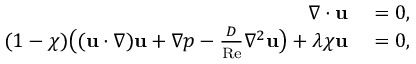Convert formula to latex. <formula><loc_0><loc_0><loc_500><loc_500>\begin{array} { r l } { \nabla \cdot u } & = 0 , } \\ { ( 1 - \chi ) \left ( ( u \cdot \nabla ) u + \nabla p - \frac { D } { R e } \nabla ^ { 2 } u \right ) + \lambda \chi u } & = 0 , } \end{array}</formula> 